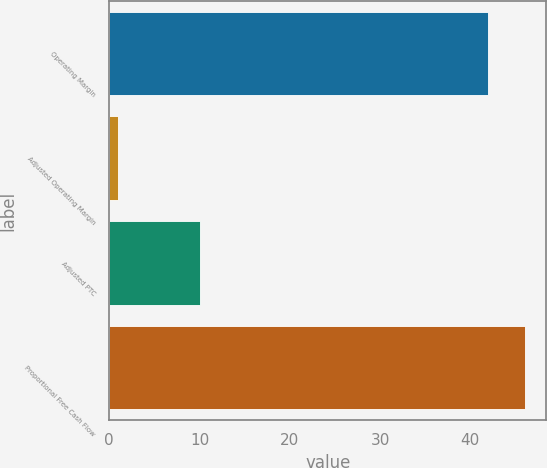<chart> <loc_0><loc_0><loc_500><loc_500><bar_chart><fcel>Operating Margin<fcel>Adjusted Operating Margin<fcel>Adjusted PTC<fcel>Proportional Free Cash Flow<nl><fcel>42<fcel>1<fcel>10<fcel>46.1<nl></chart> 